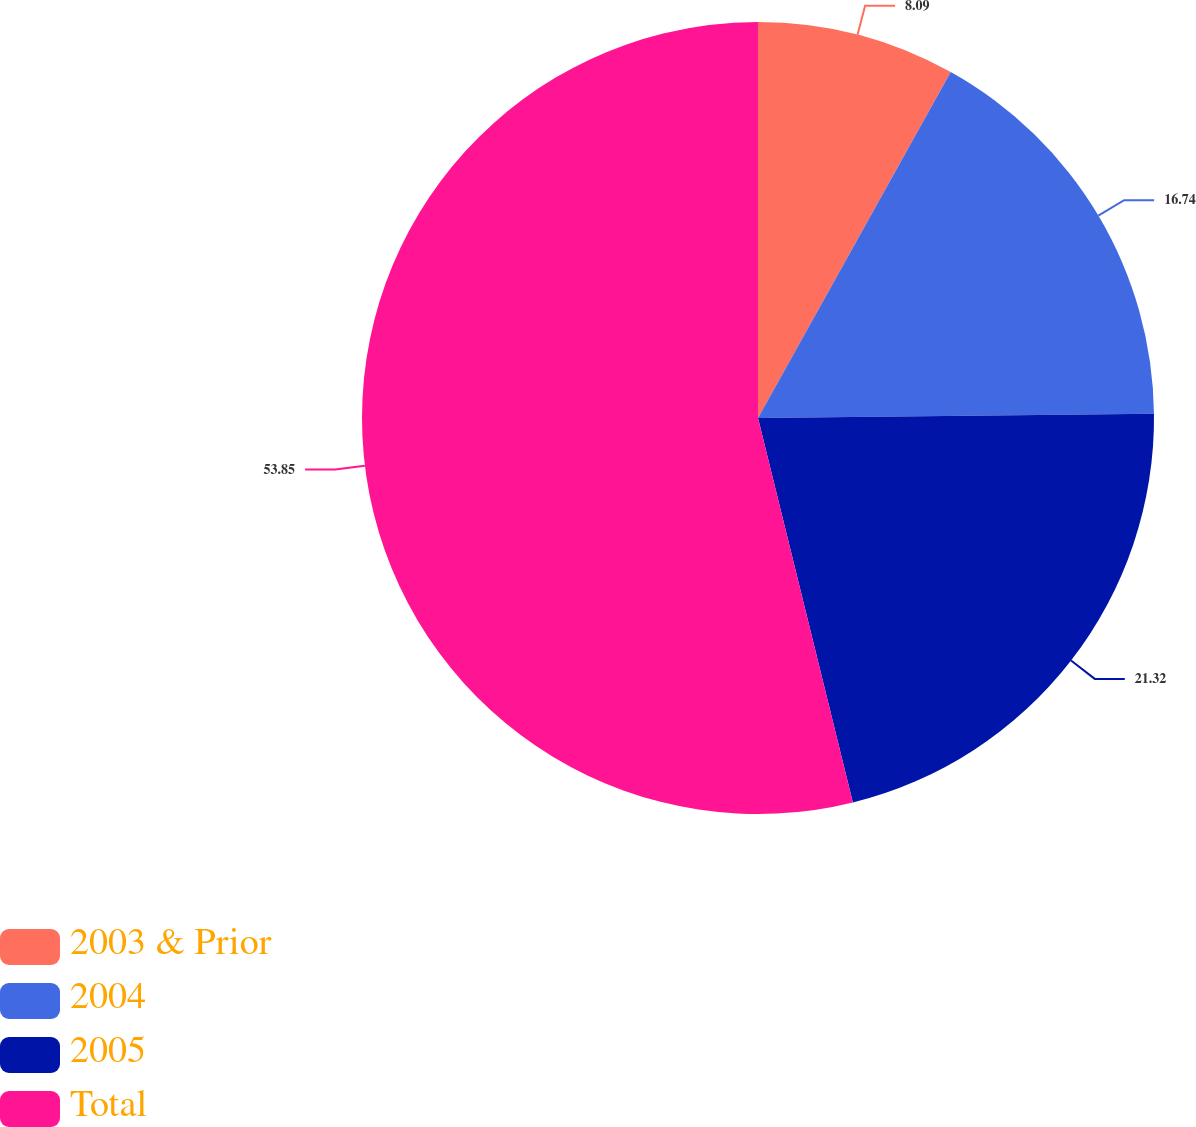Convert chart. <chart><loc_0><loc_0><loc_500><loc_500><pie_chart><fcel>2003 & Prior<fcel>2004<fcel>2005<fcel>Total<nl><fcel>8.09%<fcel>16.74%<fcel>21.32%<fcel>53.85%<nl></chart> 